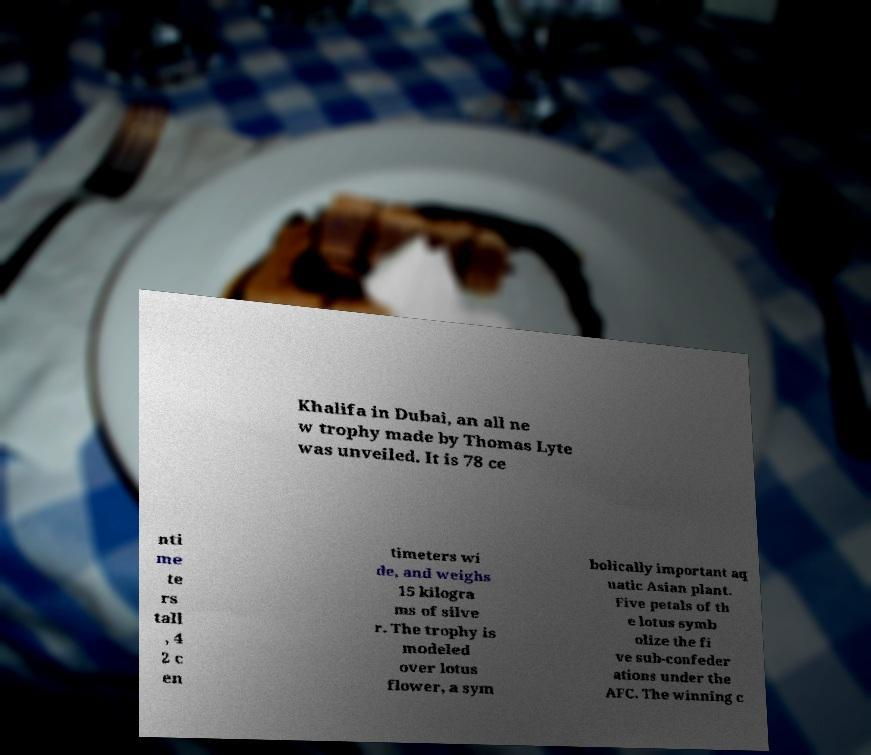Please read and relay the text visible in this image. What does it say? Khalifa in Dubai, an all ne w trophy made by Thomas Lyte was unveiled. It is 78 ce nti me te rs tall , 4 2 c en timeters wi de, and weighs 15 kilogra ms of silve r. The trophy is modeled over lotus flower, a sym bolically important aq uatic Asian plant. Five petals of th e lotus symb olize the fi ve sub-confeder ations under the AFC. The winning c 